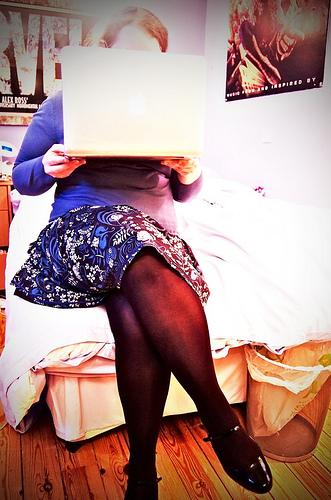Is that a man?
Concise answer only. No. Is the computer covering the lady's face?
Concise answer only. Yes. Is that a couch?
Give a very brief answer. No. What is the lady sitting on?
Be succinct. Bed. 